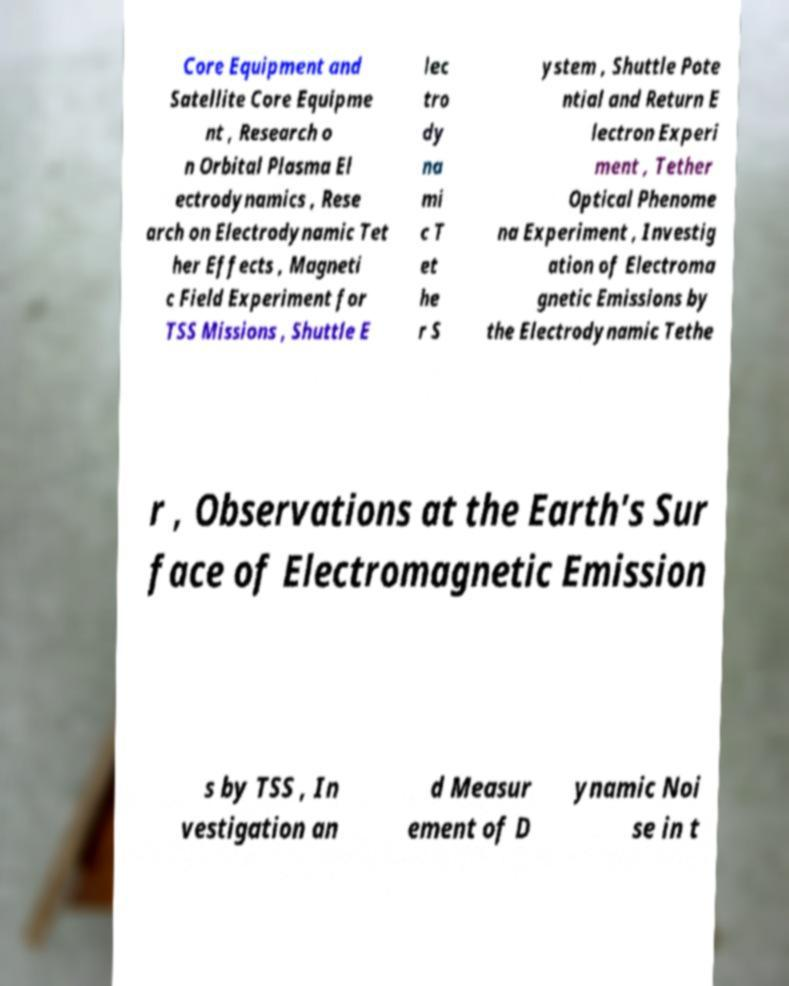Can you accurately transcribe the text from the provided image for me? Core Equipment and Satellite Core Equipme nt , Research o n Orbital Plasma El ectrodynamics , Rese arch on Electrodynamic Tet her Effects , Magneti c Field Experiment for TSS Missions , Shuttle E lec tro dy na mi c T et he r S ystem , Shuttle Pote ntial and Return E lectron Experi ment , Tether Optical Phenome na Experiment , Investig ation of Electroma gnetic Emissions by the Electrodynamic Tethe r , Observations at the Earth's Sur face of Electromagnetic Emission s by TSS , In vestigation an d Measur ement of D ynamic Noi se in t 